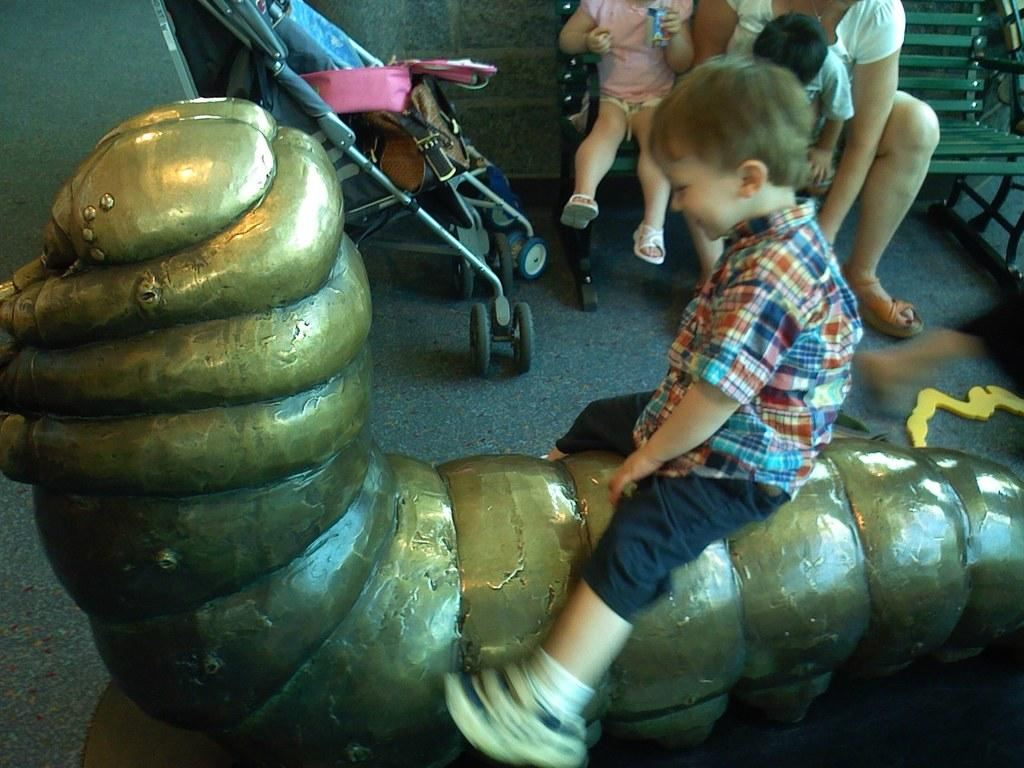What is the main subject of the image? There is a person on a sculpture in the image. What can be seen in the background of the image? There is a stroller and a wall in the background of the image. Are there any other people visible in the image? Yes, there are people on a bench in the background of the image. What type of pan is being used by the person on the sculpture in the image? There is no pan present in the image; the main subject is a person on a sculpture. 